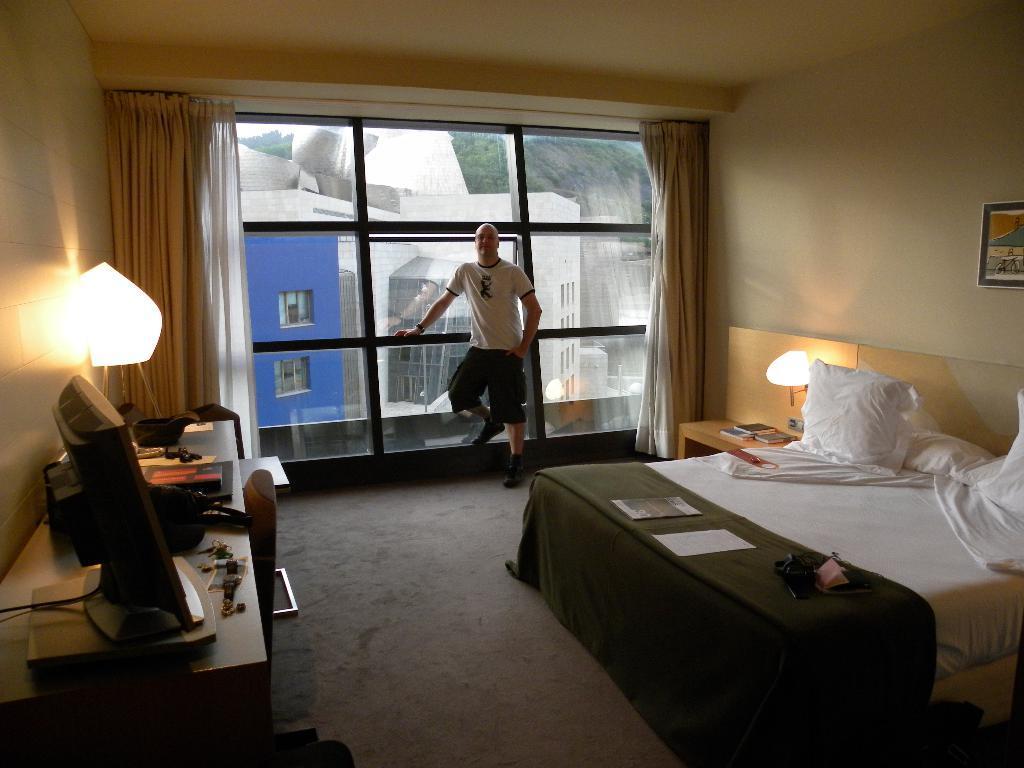Please provide a concise description of this image. This image is inside a room. There is a bed with pillows, table upon which there is a television and etc. On the right side of the image we can see a photo frame on the wall. In the background of the image there is a man standing at the glass windows. These are the curtains and buildings. 